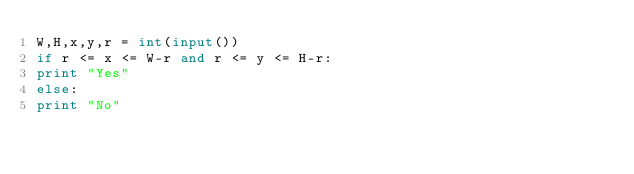<code> <loc_0><loc_0><loc_500><loc_500><_Python_>W,H,x,y,r = int(input())
if r <= x <= W-r and r <= y <= H-r:
print "Yes"
else:
print "No"</code> 